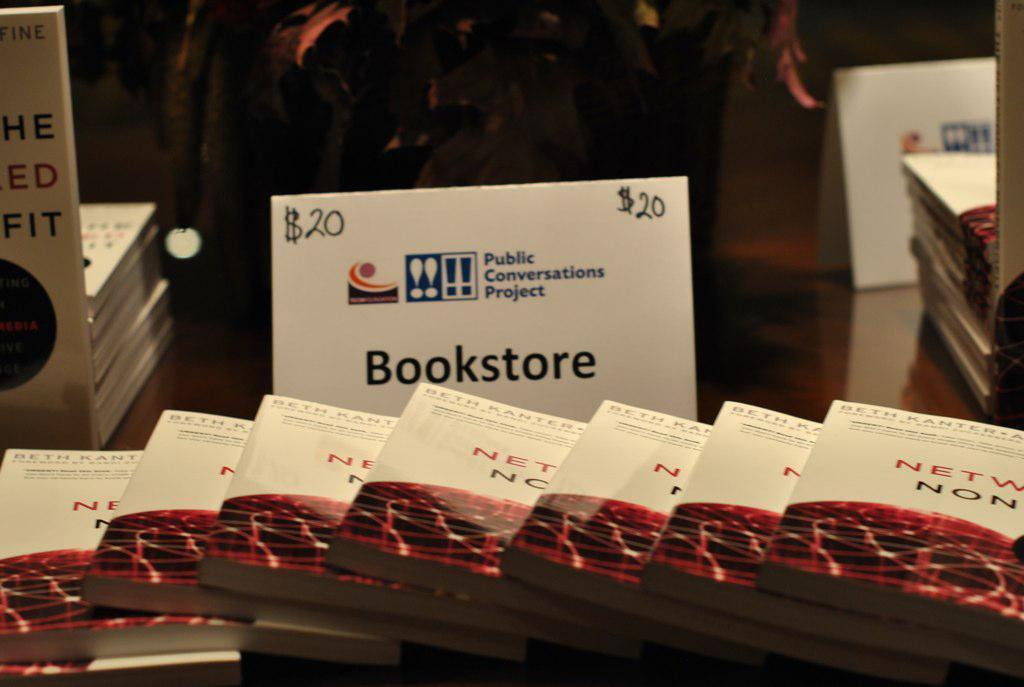How would you summarize this image in a sentence or two? In this image there is a table and we can see books and boards placed on the table. 